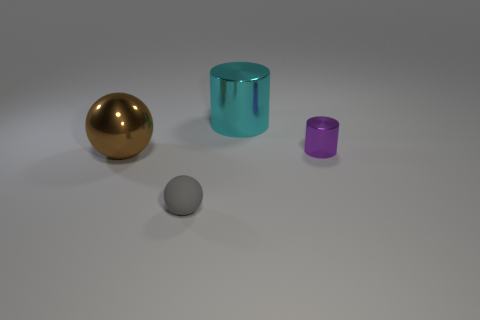Add 4 large things. How many objects exist? 8 Subtract all cylinders. Subtract all large rubber balls. How many objects are left? 2 Add 2 matte spheres. How many matte spheres are left? 3 Add 4 large cyan things. How many large cyan things exist? 5 Subtract 0 purple blocks. How many objects are left? 4 